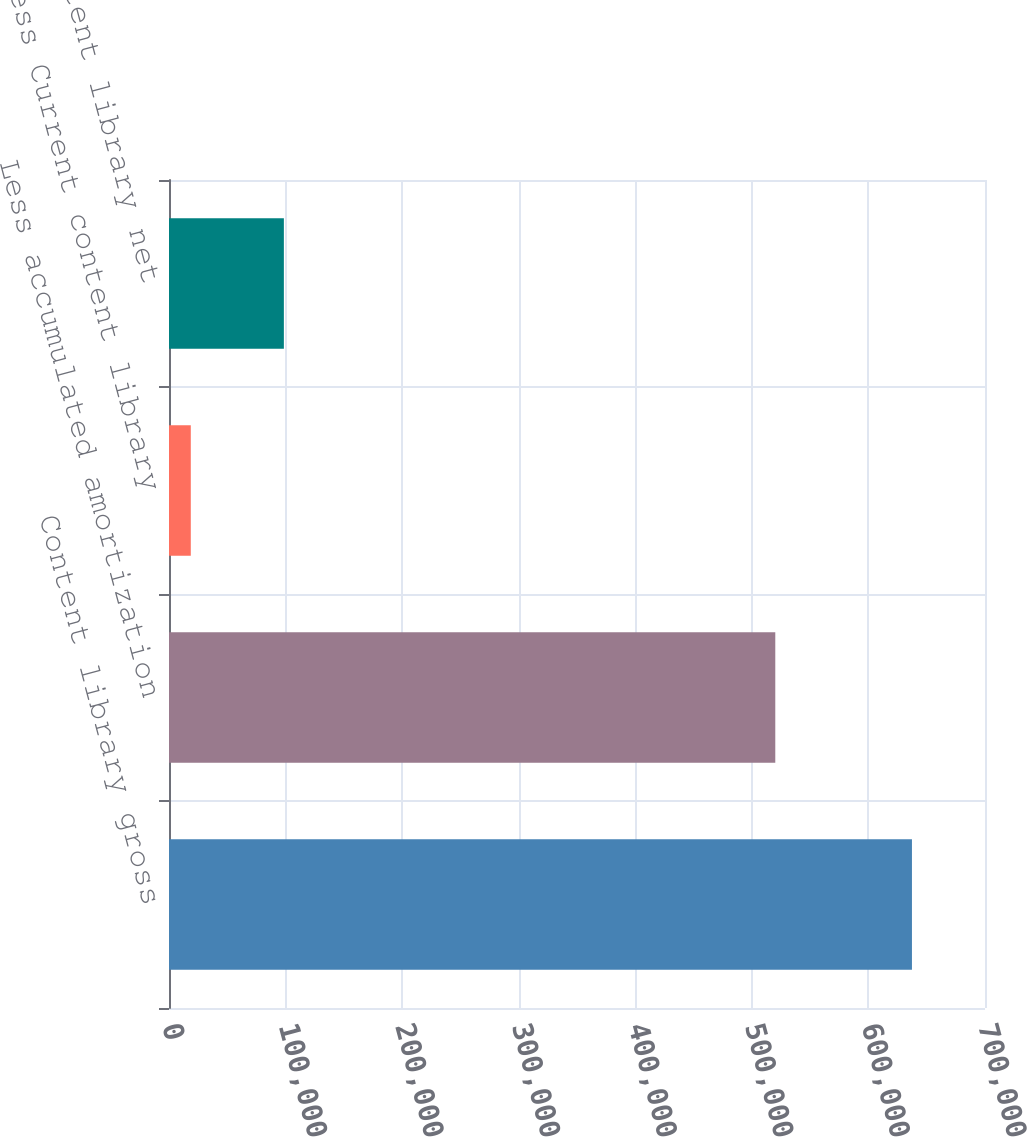<chart> <loc_0><loc_0><loc_500><loc_500><bar_chart><fcel>Content library gross<fcel>Less accumulated amortization<fcel>Less Current content library<fcel>Content library net<nl><fcel>637336<fcel>520098<fcel>18691<fcel>98547<nl></chart> 